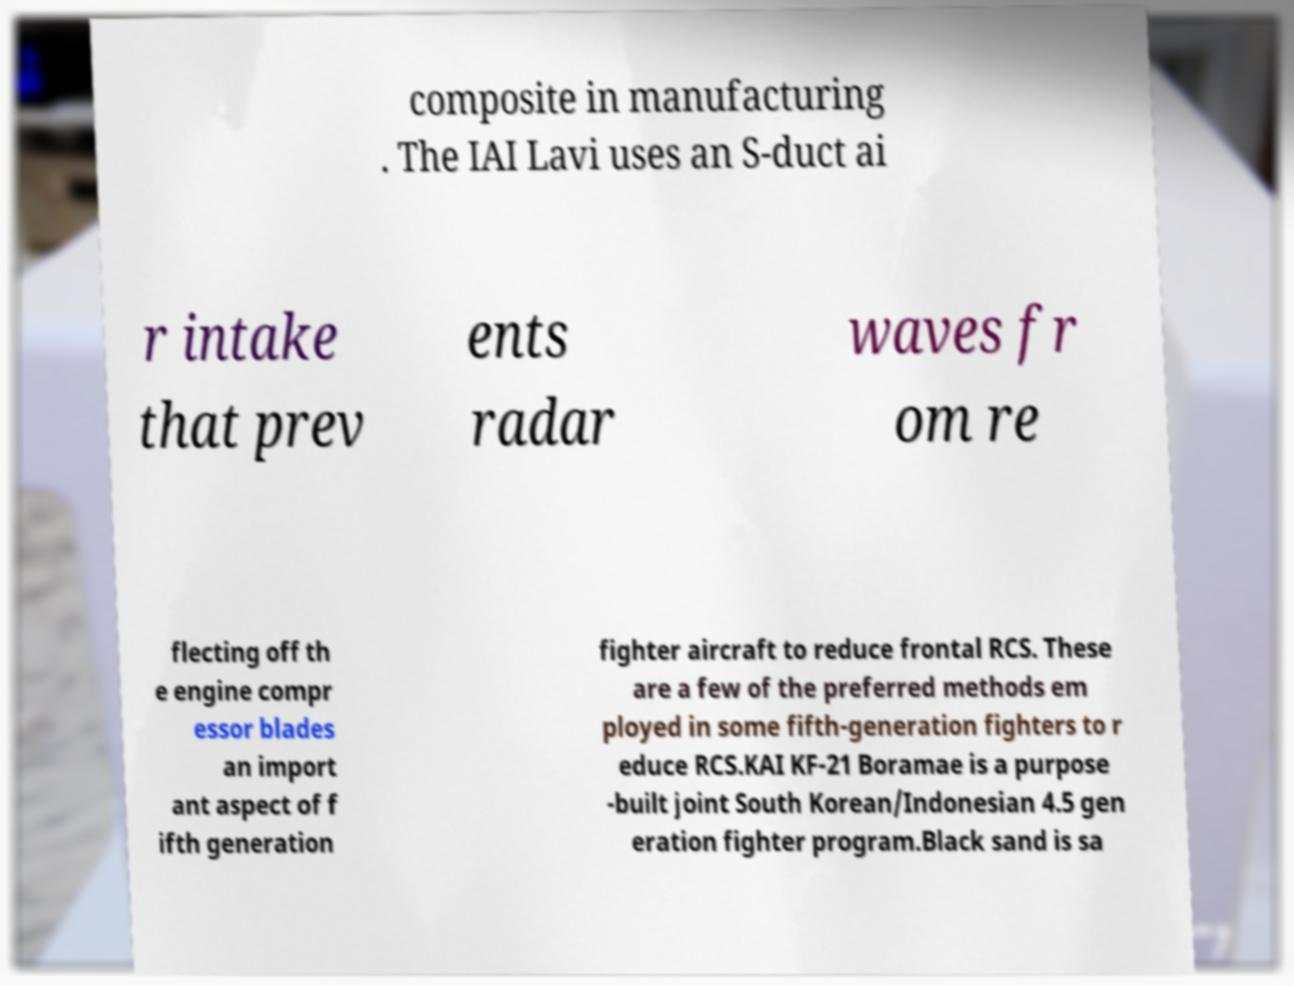What messages or text are displayed in this image? I need them in a readable, typed format. composite in manufacturing . The IAI Lavi uses an S-duct ai r intake that prev ents radar waves fr om re flecting off th e engine compr essor blades an import ant aspect of f ifth generation fighter aircraft to reduce frontal RCS. These are a few of the preferred methods em ployed in some fifth-generation fighters to r educe RCS.KAI KF-21 Boramae is a purpose -built joint South Korean/Indonesian 4.5 gen eration fighter program.Black sand is sa 